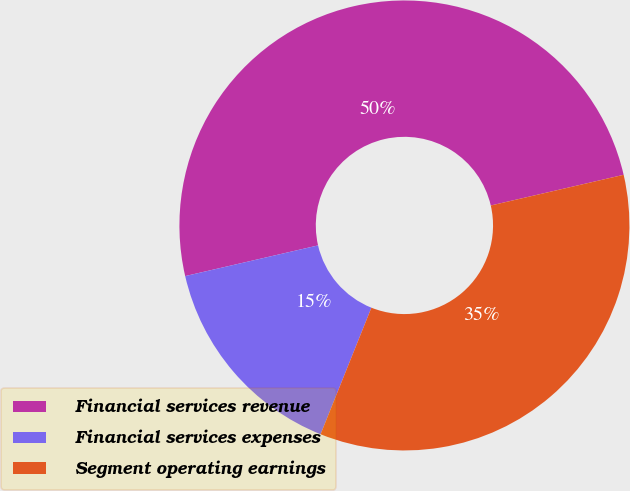Convert chart. <chart><loc_0><loc_0><loc_500><loc_500><pie_chart><fcel>Financial services revenue<fcel>Financial services expenses<fcel>Segment operating earnings<nl><fcel>50.0%<fcel>15.31%<fcel>34.69%<nl></chart> 